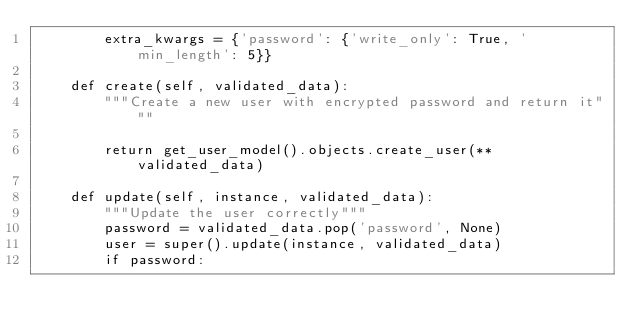Convert code to text. <code><loc_0><loc_0><loc_500><loc_500><_Python_>        extra_kwargs = {'password': {'write_only': True, 'min_length': 5}}

    def create(self, validated_data):
        """Create a new user with encrypted password and return it"""

        return get_user_model().objects.create_user(**validated_data)

    def update(self, instance, validated_data):
        """Update the user correctly"""
        password = validated_data.pop('password', None)
        user = super().update(instance, validated_data)
        if password:</code> 